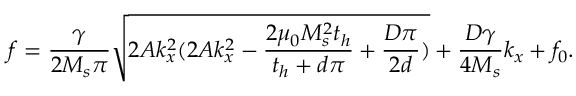<formula> <loc_0><loc_0><loc_500><loc_500>f = \frac { \gamma } { 2 M _ { s } \pi } \sqrt { 2 A k _ { x } ^ { 2 } ( 2 A k _ { x } ^ { 2 } - \frac { 2 \mu _ { 0 } M _ { s } ^ { 2 } t _ { h } } { t _ { h } + d \pi } + \frac { D \pi } { 2 d } ) } + \frac { D \gamma } { 4 M _ { s } } k _ { x } + f _ { 0 } .</formula> 